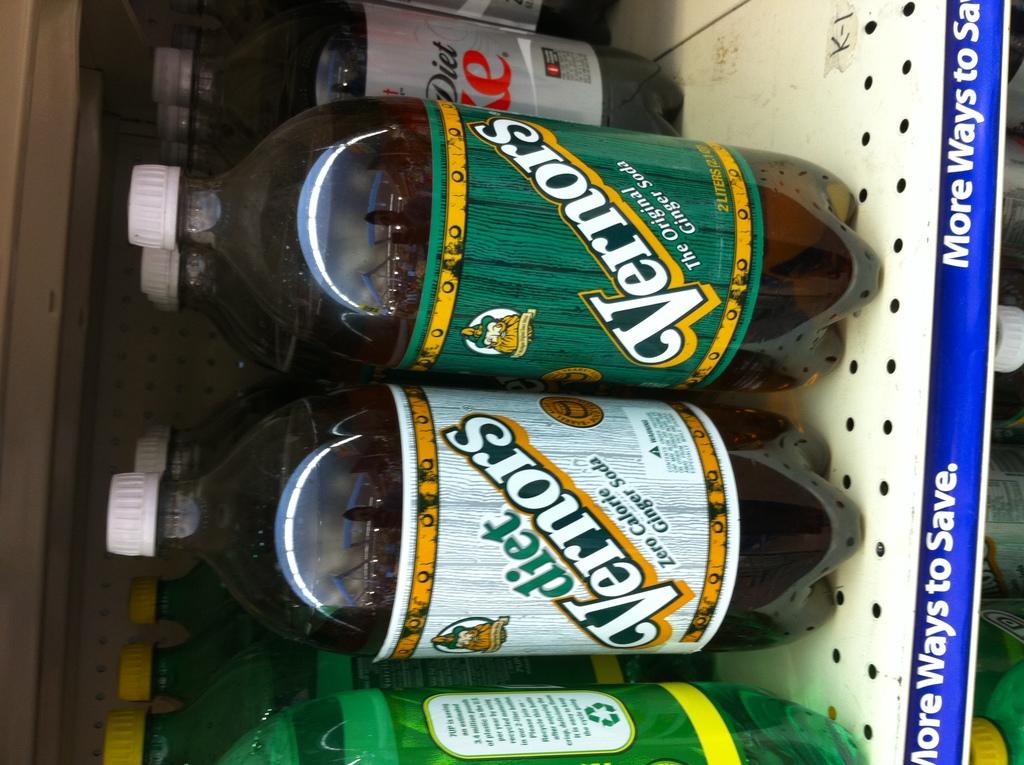What is this brand of soda?
Ensure brevity in your answer.  Vernors. Is the soda in the back row diet or no?
Provide a short and direct response. Yes. 